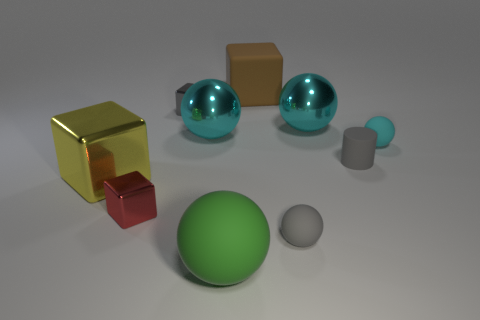Are there more small blocks that are to the right of the green object than cyan rubber balls?
Ensure brevity in your answer.  No. Is there any other thing that has the same material as the yellow object?
Give a very brief answer. Yes. What shape is the small matte object that is the same color as the cylinder?
Offer a very short reply. Sphere. How many cylinders are small cyan objects or cyan shiny objects?
Offer a terse response. 0. There is a shiny thing that is to the right of the tiny rubber ball that is in front of the small cyan rubber ball; what color is it?
Keep it short and to the point. Cyan. There is a tiny matte cylinder; is it the same color as the large matte thing that is in front of the gray rubber cylinder?
Ensure brevity in your answer.  No. What size is the gray cylinder that is the same material as the big green thing?
Offer a terse response. Small. What size is the matte sphere that is the same color as the small cylinder?
Give a very brief answer. Small. Is the small matte cylinder the same color as the large matte ball?
Your response must be concise. No. There is a metallic block that is behind the cyan object that is right of the gray cylinder; are there any large metal spheres to the left of it?
Make the answer very short. No. 